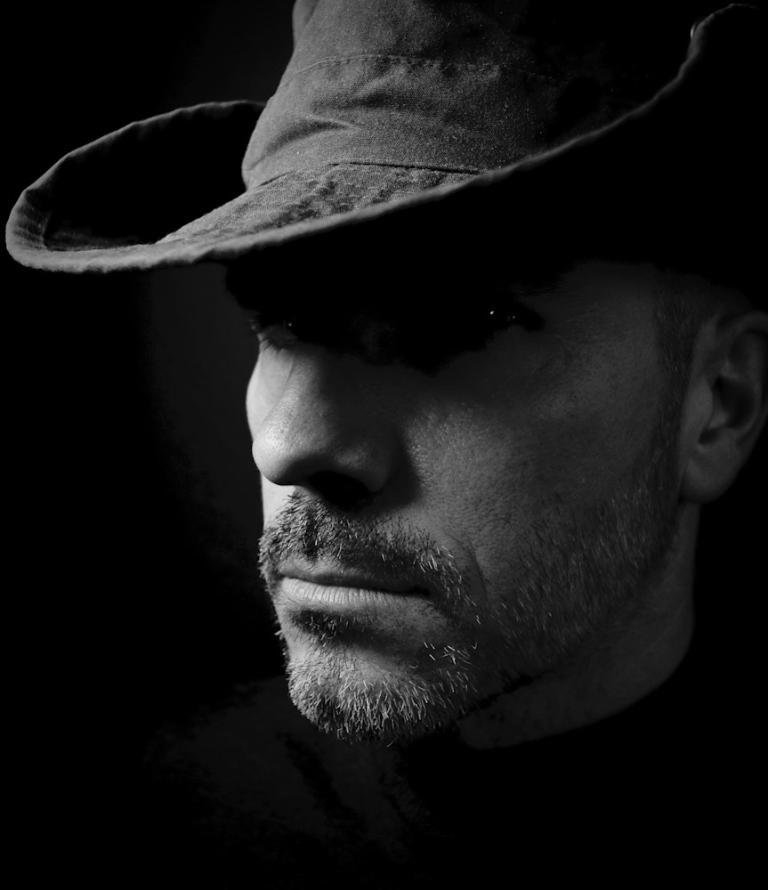What is the color scheme of the image? The image is black and white. Can you describe the person in the image? There is a man in the image. What is the man wearing on his head? The man is wearing a hat. What type of quill is the man holding in the image? There is no quill present in the image; it is a black and white image of a man wearing a hat. 